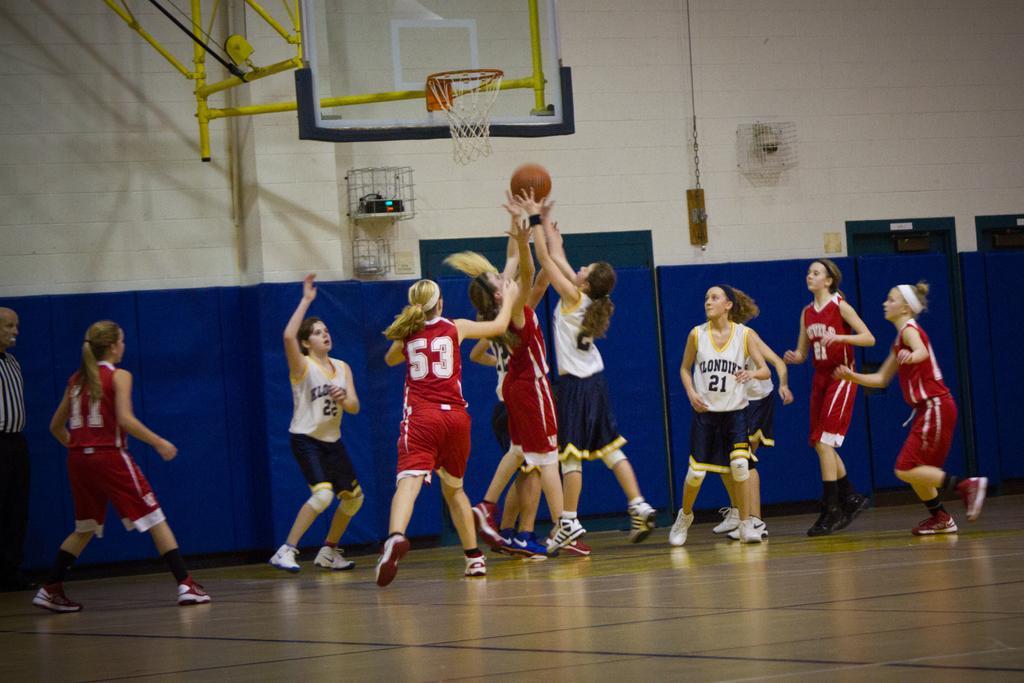How would you summarize this image in a sentence or two? In this image there are a group of people who are playing basketball, and there is one ball. In the background there is pole, net, boards and some objects on the wall. At the bottom there is floor. 